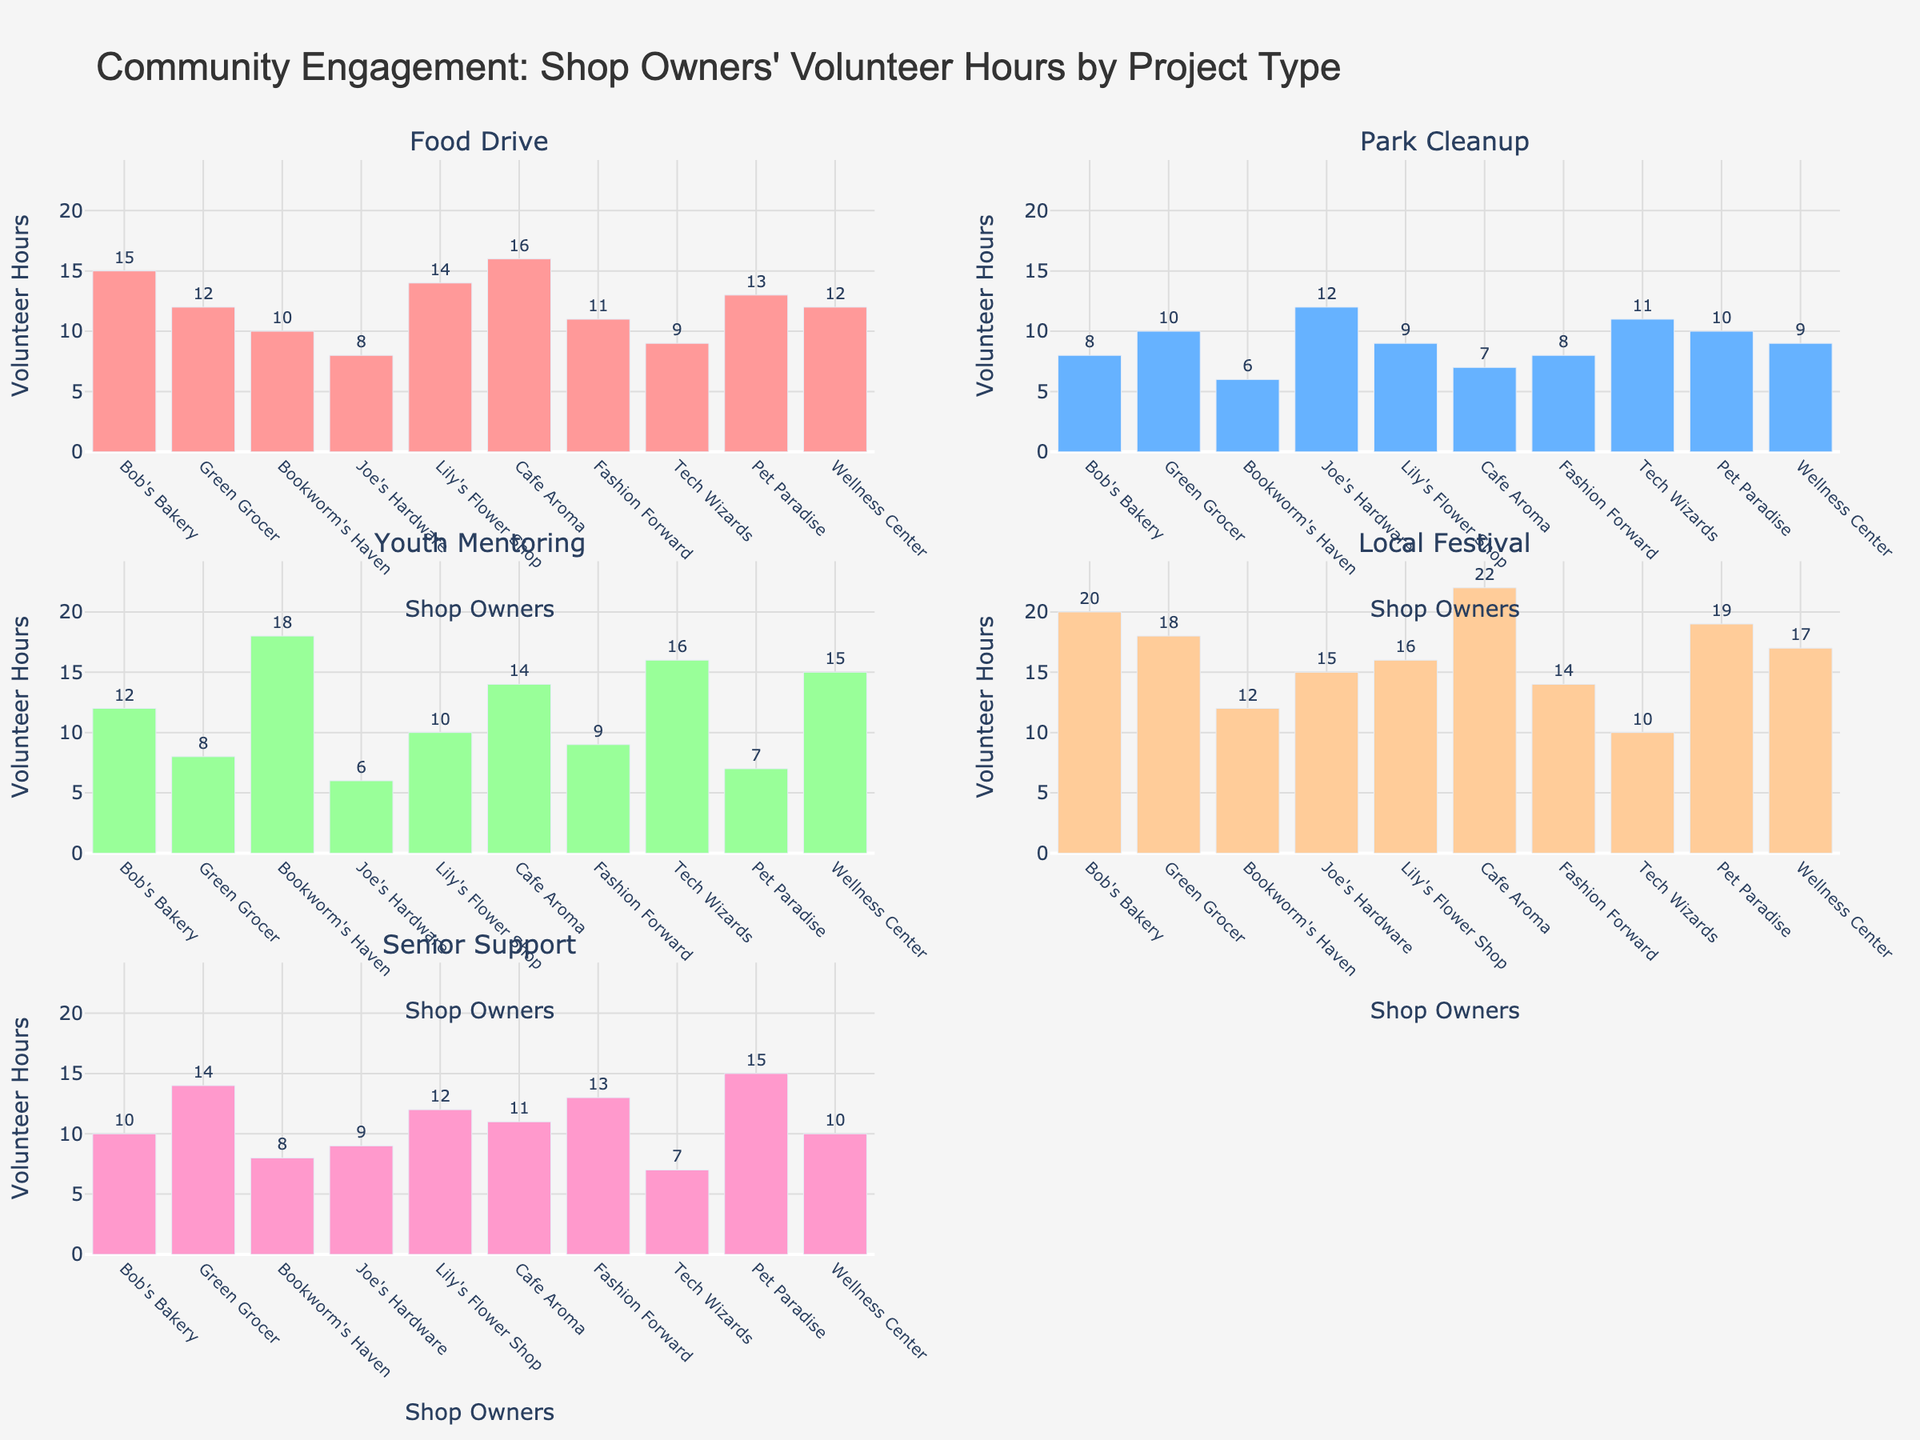Which shop owner contributed the most hours to the Food Drive? Look for the highest bar in the Food Drive subplot. Cafe Aroma has the highest bar at 16 hours.
Answer: Cafe Aroma What is the total number of hours contributed by Green Grocer across all projects? Sum the hours Green Grocer contributed to each project: 12 (Food Drive) + 10 (Park Cleanup) + 8 (Youth Mentoring) + 18 (Local Festival) + 14 (Senior Support) = 62 hours.
Answer: 62 Who contributed more hours to Youth Mentoring, Bookworm's Haven or Tech Wizards? Compare the height of the bars for Bookworm's Haven (18 hours) and Tech Wizards (16 hours) in the Youth Mentoring subplot. Bookworm's Haven has a higher bar.
Answer: Bookworm's Haven Which project type received the most volunteer hours from Lily's Flower Shop? Identify the highest bar for Lily's Flower Shop across all subplots. The highest bar is for Local Festival at 16 hours.
Answer: Local Festival What is the average number of hours contributed to the Park Cleanup across all shop owners? Sum the hours contributed by each shop owner to the Park Cleanup and divide by the number of shop owners: (8+10+6+12+9+7+8+11+10+9) / 10 = 9 hours.
Answer: 9 Did Joe's Hardware contribute more hours to Senior Support or Park Cleanup? Compare the bars for Joe's Hardware in the Park Cleanup (12 hours) and Senior Support (9 hours) subplots. Joe's Hardware contributed more to Park Cleanup.
Answer: Park Cleanup What is the median number of hours contributed by all shop owners to the Local Festival? List the hours contributed by each shop owner to the Local Festival and sort them: 10, 12, 14, 15, 16, 17, 18, 19, 20, 22. The median value, being the middle value of the sorted list, is (16+17)/2 = 16.5 hours.
Answer: 16.5 Which project type received the least volunteer hours from Pet Paradise? Identify the lowest bar for Pet Paradise across all subplots. The lowest value is for Youth Mentoring at 7 hours.
Answer: Youth Mentoring What is the difference in volunteer hours between the most and least contributing shop owners for the Senior Support project? Identify the maximum and minimum hours contributed to the Senior Support project: 15 hours (Pet Paradise) - 7 hours (Tech Wizards) = 8 hours.
Answer: 8 